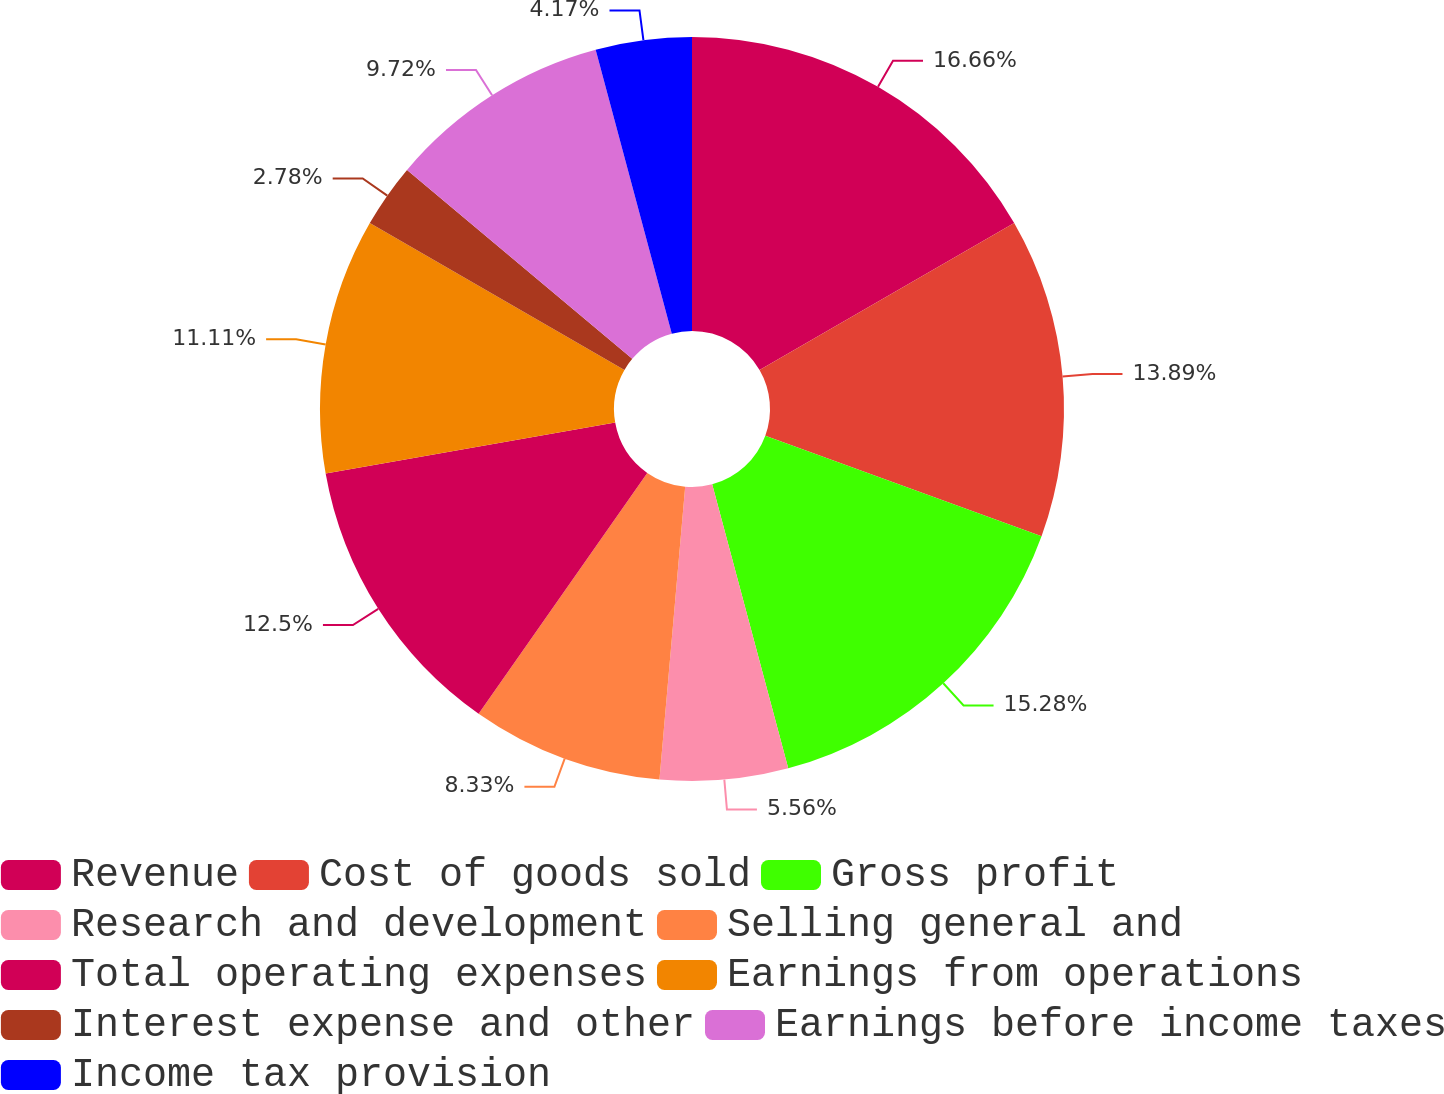Convert chart to OTSL. <chart><loc_0><loc_0><loc_500><loc_500><pie_chart><fcel>Revenue<fcel>Cost of goods sold<fcel>Gross profit<fcel>Research and development<fcel>Selling general and<fcel>Total operating expenses<fcel>Earnings from operations<fcel>Interest expense and other<fcel>Earnings before income taxes<fcel>Income tax provision<nl><fcel>16.67%<fcel>13.89%<fcel>15.28%<fcel>5.56%<fcel>8.33%<fcel>12.5%<fcel>11.11%<fcel>2.78%<fcel>9.72%<fcel>4.17%<nl></chart> 